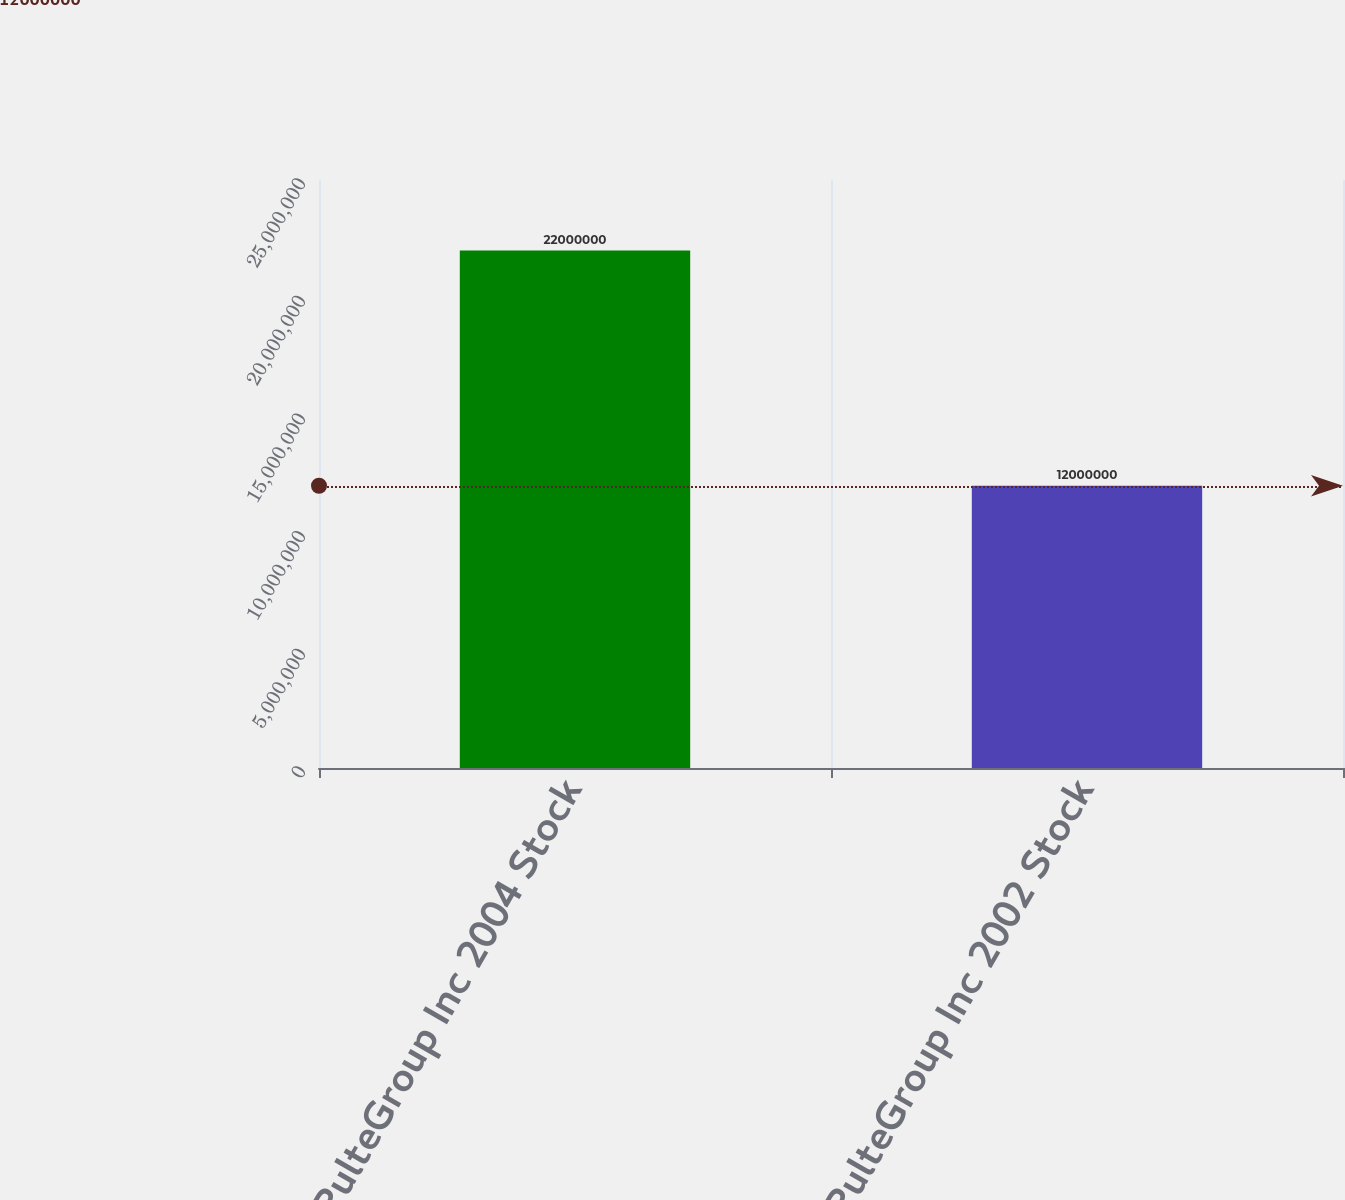Convert chart to OTSL. <chart><loc_0><loc_0><loc_500><loc_500><bar_chart><fcel>PulteGroup Inc 2004 Stock<fcel>PulteGroup Inc 2002 Stock<nl><fcel>2.2e+07<fcel>1.2e+07<nl></chart> 